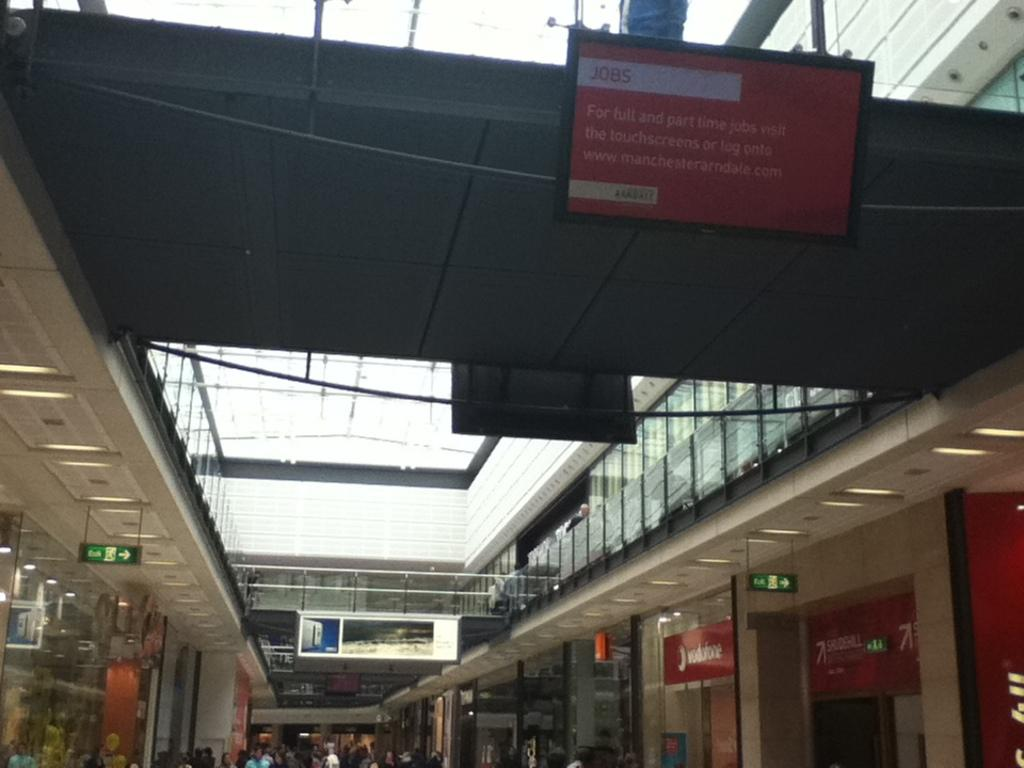What type of structure is present in the image? There is a building in the image. Are there any living beings in the image? Yes, there are people in the image. What can be seen at the top of the image? The sky is visible at the top of the image. What is hanging or displayed in the image? There is a banner in the image. How much money is being exchanged between the people in the image? There is no indication of money or any exchange of money in the image. 